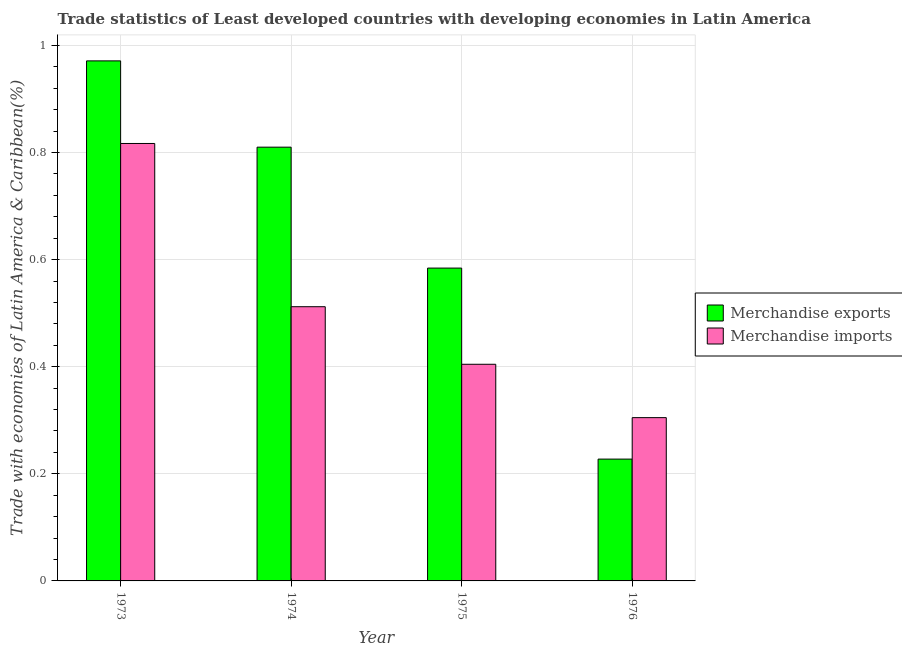Are the number of bars per tick equal to the number of legend labels?
Offer a terse response. Yes. Are the number of bars on each tick of the X-axis equal?
Offer a terse response. Yes. How many bars are there on the 3rd tick from the right?
Keep it short and to the point. 2. What is the label of the 2nd group of bars from the left?
Give a very brief answer. 1974. In how many cases, is the number of bars for a given year not equal to the number of legend labels?
Your response must be concise. 0. What is the merchandise exports in 1976?
Your answer should be very brief. 0.23. Across all years, what is the maximum merchandise imports?
Offer a very short reply. 0.82. Across all years, what is the minimum merchandise imports?
Your answer should be very brief. 0.3. In which year was the merchandise imports minimum?
Ensure brevity in your answer.  1976. What is the total merchandise exports in the graph?
Ensure brevity in your answer.  2.59. What is the difference between the merchandise imports in 1974 and that in 1975?
Make the answer very short. 0.11. What is the difference between the merchandise imports in 1975 and the merchandise exports in 1974?
Your answer should be very brief. -0.11. What is the average merchandise imports per year?
Your answer should be very brief. 0.51. What is the ratio of the merchandise exports in 1974 to that in 1976?
Provide a short and direct response. 3.56. Is the merchandise imports in 1973 less than that in 1976?
Offer a terse response. No. Is the difference between the merchandise exports in 1973 and 1974 greater than the difference between the merchandise imports in 1973 and 1974?
Keep it short and to the point. No. What is the difference between the highest and the second highest merchandise exports?
Make the answer very short. 0.16. What is the difference between the highest and the lowest merchandise exports?
Offer a terse response. 0.74. In how many years, is the merchandise exports greater than the average merchandise exports taken over all years?
Offer a very short reply. 2. What does the 1st bar from the left in 1975 represents?
Give a very brief answer. Merchandise exports. Does the graph contain any zero values?
Offer a terse response. No. Does the graph contain grids?
Give a very brief answer. Yes. Where does the legend appear in the graph?
Offer a terse response. Center right. How many legend labels are there?
Your response must be concise. 2. How are the legend labels stacked?
Your answer should be very brief. Vertical. What is the title of the graph?
Your response must be concise. Trade statistics of Least developed countries with developing economies in Latin America. Does "Personal remittances" appear as one of the legend labels in the graph?
Give a very brief answer. No. What is the label or title of the X-axis?
Provide a short and direct response. Year. What is the label or title of the Y-axis?
Offer a terse response. Trade with economies of Latin America & Caribbean(%). What is the Trade with economies of Latin America & Caribbean(%) in Merchandise exports in 1973?
Your answer should be very brief. 0.97. What is the Trade with economies of Latin America & Caribbean(%) in Merchandise imports in 1973?
Make the answer very short. 0.82. What is the Trade with economies of Latin America & Caribbean(%) in Merchandise exports in 1974?
Keep it short and to the point. 0.81. What is the Trade with economies of Latin America & Caribbean(%) in Merchandise imports in 1974?
Keep it short and to the point. 0.51. What is the Trade with economies of Latin America & Caribbean(%) in Merchandise exports in 1975?
Keep it short and to the point. 0.58. What is the Trade with economies of Latin America & Caribbean(%) of Merchandise imports in 1975?
Give a very brief answer. 0.4. What is the Trade with economies of Latin America & Caribbean(%) of Merchandise exports in 1976?
Your response must be concise. 0.23. What is the Trade with economies of Latin America & Caribbean(%) of Merchandise imports in 1976?
Offer a terse response. 0.3. Across all years, what is the maximum Trade with economies of Latin America & Caribbean(%) of Merchandise exports?
Offer a very short reply. 0.97. Across all years, what is the maximum Trade with economies of Latin America & Caribbean(%) of Merchandise imports?
Make the answer very short. 0.82. Across all years, what is the minimum Trade with economies of Latin America & Caribbean(%) in Merchandise exports?
Provide a short and direct response. 0.23. Across all years, what is the minimum Trade with economies of Latin America & Caribbean(%) in Merchandise imports?
Your answer should be very brief. 0.3. What is the total Trade with economies of Latin America & Caribbean(%) of Merchandise exports in the graph?
Offer a terse response. 2.59. What is the total Trade with economies of Latin America & Caribbean(%) in Merchandise imports in the graph?
Your response must be concise. 2.04. What is the difference between the Trade with economies of Latin America & Caribbean(%) in Merchandise exports in 1973 and that in 1974?
Keep it short and to the point. 0.16. What is the difference between the Trade with economies of Latin America & Caribbean(%) of Merchandise imports in 1973 and that in 1974?
Keep it short and to the point. 0.3. What is the difference between the Trade with economies of Latin America & Caribbean(%) of Merchandise exports in 1973 and that in 1975?
Offer a terse response. 0.39. What is the difference between the Trade with economies of Latin America & Caribbean(%) of Merchandise imports in 1973 and that in 1975?
Ensure brevity in your answer.  0.41. What is the difference between the Trade with economies of Latin America & Caribbean(%) in Merchandise exports in 1973 and that in 1976?
Your response must be concise. 0.74. What is the difference between the Trade with economies of Latin America & Caribbean(%) of Merchandise imports in 1973 and that in 1976?
Make the answer very short. 0.51. What is the difference between the Trade with economies of Latin America & Caribbean(%) of Merchandise exports in 1974 and that in 1975?
Make the answer very short. 0.23. What is the difference between the Trade with economies of Latin America & Caribbean(%) of Merchandise imports in 1974 and that in 1975?
Your answer should be very brief. 0.11. What is the difference between the Trade with economies of Latin America & Caribbean(%) of Merchandise exports in 1974 and that in 1976?
Offer a very short reply. 0.58. What is the difference between the Trade with economies of Latin America & Caribbean(%) of Merchandise imports in 1974 and that in 1976?
Make the answer very short. 0.21. What is the difference between the Trade with economies of Latin America & Caribbean(%) in Merchandise exports in 1975 and that in 1976?
Give a very brief answer. 0.36. What is the difference between the Trade with economies of Latin America & Caribbean(%) in Merchandise imports in 1975 and that in 1976?
Offer a very short reply. 0.1. What is the difference between the Trade with economies of Latin America & Caribbean(%) of Merchandise exports in 1973 and the Trade with economies of Latin America & Caribbean(%) of Merchandise imports in 1974?
Make the answer very short. 0.46. What is the difference between the Trade with economies of Latin America & Caribbean(%) in Merchandise exports in 1973 and the Trade with economies of Latin America & Caribbean(%) in Merchandise imports in 1975?
Give a very brief answer. 0.57. What is the difference between the Trade with economies of Latin America & Caribbean(%) in Merchandise exports in 1973 and the Trade with economies of Latin America & Caribbean(%) in Merchandise imports in 1976?
Your answer should be very brief. 0.67. What is the difference between the Trade with economies of Latin America & Caribbean(%) in Merchandise exports in 1974 and the Trade with economies of Latin America & Caribbean(%) in Merchandise imports in 1975?
Make the answer very short. 0.41. What is the difference between the Trade with economies of Latin America & Caribbean(%) in Merchandise exports in 1974 and the Trade with economies of Latin America & Caribbean(%) in Merchandise imports in 1976?
Your response must be concise. 0.51. What is the difference between the Trade with economies of Latin America & Caribbean(%) in Merchandise exports in 1975 and the Trade with economies of Latin America & Caribbean(%) in Merchandise imports in 1976?
Offer a very short reply. 0.28. What is the average Trade with economies of Latin America & Caribbean(%) in Merchandise exports per year?
Make the answer very short. 0.65. What is the average Trade with economies of Latin America & Caribbean(%) of Merchandise imports per year?
Provide a short and direct response. 0.51. In the year 1973, what is the difference between the Trade with economies of Latin America & Caribbean(%) in Merchandise exports and Trade with economies of Latin America & Caribbean(%) in Merchandise imports?
Ensure brevity in your answer.  0.15. In the year 1974, what is the difference between the Trade with economies of Latin America & Caribbean(%) of Merchandise exports and Trade with economies of Latin America & Caribbean(%) of Merchandise imports?
Your response must be concise. 0.3. In the year 1975, what is the difference between the Trade with economies of Latin America & Caribbean(%) of Merchandise exports and Trade with economies of Latin America & Caribbean(%) of Merchandise imports?
Offer a terse response. 0.18. In the year 1976, what is the difference between the Trade with economies of Latin America & Caribbean(%) of Merchandise exports and Trade with economies of Latin America & Caribbean(%) of Merchandise imports?
Offer a terse response. -0.08. What is the ratio of the Trade with economies of Latin America & Caribbean(%) in Merchandise exports in 1973 to that in 1974?
Ensure brevity in your answer.  1.2. What is the ratio of the Trade with economies of Latin America & Caribbean(%) in Merchandise imports in 1973 to that in 1974?
Your answer should be very brief. 1.6. What is the ratio of the Trade with economies of Latin America & Caribbean(%) of Merchandise exports in 1973 to that in 1975?
Make the answer very short. 1.66. What is the ratio of the Trade with economies of Latin America & Caribbean(%) of Merchandise imports in 1973 to that in 1975?
Ensure brevity in your answer.  2.02. What is the ratio of the Trade with economies of Latin America & Caribbean(%) in Merchandise exports in 1973 to that in 1976?
Your answer should be very brief. 4.27. What is the ratio of the Trade with economies of Latin America & Caribbean(%) in Merchandise imports in 1973 to that in 1976?
Make the answer very short. 2.68. What is the ratio of the Trade with economies of Latin America & Caribbean(%) in Merchandise exports in 1974 to that in 1975?
Your response must be concise. 1.39. What is the ratio of the Trade with economies of Latin America & Caribbean(%) in Merchandise imports in 1974 to that in 1975?
Offer a terse response. 1.27. What is the ratio of the Trade with economies of Latin America & Caribbean(%) of Merchandise exports in 1974 to that in 1976?
Offer a terse response. 3.56. What is the ratio of the Trade with economies of Latin America & Caribbean(%) in Merchandise imports in 1974 to that in 1976?
Offer a terse response. 1.68. What is the ratio of the Trade with economies of Latin America & Caribbean(%) of Merchandise exports in 1975 to that in 1976?
Give a very brief answer. 2.57. What is the ratio of the Trade with economies of Latin America & Caribbean(%) of Merchandise imports in 1975 to that in 1976?
Your response must be concise. 1.33. What is the difference between the highest and the second highest Trade with economies of Latin America & Caribbean(%) in Merchandise exports?
Keep it short and to the point. 0.16. What is the difference between the highest and the second highest Trade with economies of Latin America & Caribbean(%) in Merchandise imports?
Give a very brief answer. 0.3. What is the difference between the highest and the lowest Trade with economies of Latin America & Caribbean(%) in Merchandise exports?
Your response must be concise. 0.74. What is the difference between the highest and the lowest Trade with economies of Latin America & Caribbean(%) of Merchandise imports?
Ensure brevity in your answer.  0.51. 